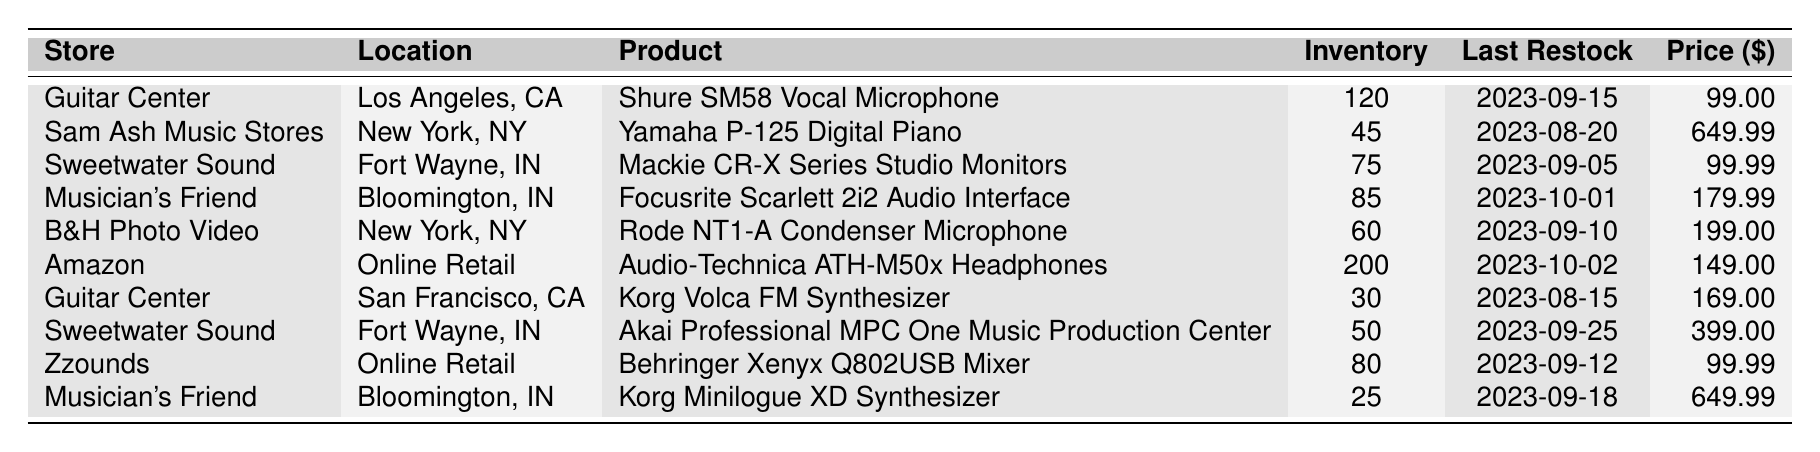What is the inventory level of the Yamaha P-125 Digital Piano at Sam Ash Music Stores? The inventory level is specifically mentioned in the table for the product at that store. By referring to the row for Sam Ash Music Stores, it shows that the inventory level for the Yamaha P-125 Digital Piano is 45.
Answer: 45 Which store has the highest inventory level? To find the store with the highest inventory, we need to compare the inventory levels of all products listed. Scanning through the table, Amazon has an inventory level of 200, which is higher than any other store.
Answer: Amazon What is the most recent restock date for the Focusrite Scarlett 2i2 Audio Interface? The last restock date is given in the same row as the product, specifically for Musician's Friend. Looking at that row, the last restock date for the Focusrite Scarlett 2i2 is noted as 2023-10-01.
Answer: 2023-10-01 What is the total inventory level for all products listed in the table? To calculate the total inventory, we need to add up the inventory levels from each row in the table. The individual levels are 120, 45, 75, 85, 60, 200, 30, 50, 80, and 25. Adding these gives: 120 + 45 + 75 + 85 + 60 + 200 + 30 + 50 + 80 + 25 = 1050.
Answer: 1050 Is the inventory level for the Behringer Xenyx Q802USB Mixer equal to the inventory level of the Korg Minilogue XD Synthesizer? The inventory level for the Behringer Xenyx Q802USB Mixer is 80, and for the Korg Minilogue XD Synthesizer, it's 25. Since 80 is not equal to 25, the statement is false.
Answer: No Which product has the lowest inventory level and what is that level? To identify the product with the lowest inventory, we look for the smallest number in the inventory levels. Among the products, the Korg Minilogue XD Synthesizer has the lowest inventory level of 25.
Answer: Korg Minilogue XD Synthesizer, 25 How many stores have an inventory level of 80 or more? We need to count the rows with inventory levels of 80 or more. The products with levels of 80 or more are the Shure SM58 Vocal Microphone (120), Audio-Technica ATH-M50x Headphones (200), Focusrite Scarlett 2i2 Audio Interface (85), Rode NT1-A Condenser Microphone (60), Behringer Xenyx Q802USB Mixer (80). Therefore, there are five stores fitting this criterion.
Answer: 5 Did Guitar Center restock any product after September 1, 2023? Checking the restock dates for the products at Guitar Center, we have Shure SM58 on September 15 and Korg Volca FM on August 15. Since the Shure SM58 was restocked after September 1, the answer is yes.
Answer: Yes What is the price difference between the most expensive and the least expensive item in the table? The highest price listed in the table is for the Yamaha P-125 Digital Piano at 649.99, and the lowest price is for the Shure SM58 Vocal Microphone at 99.00. The price difference is calculated as 649.99 - 99.00 = 550.99.
Answer: 550.99 